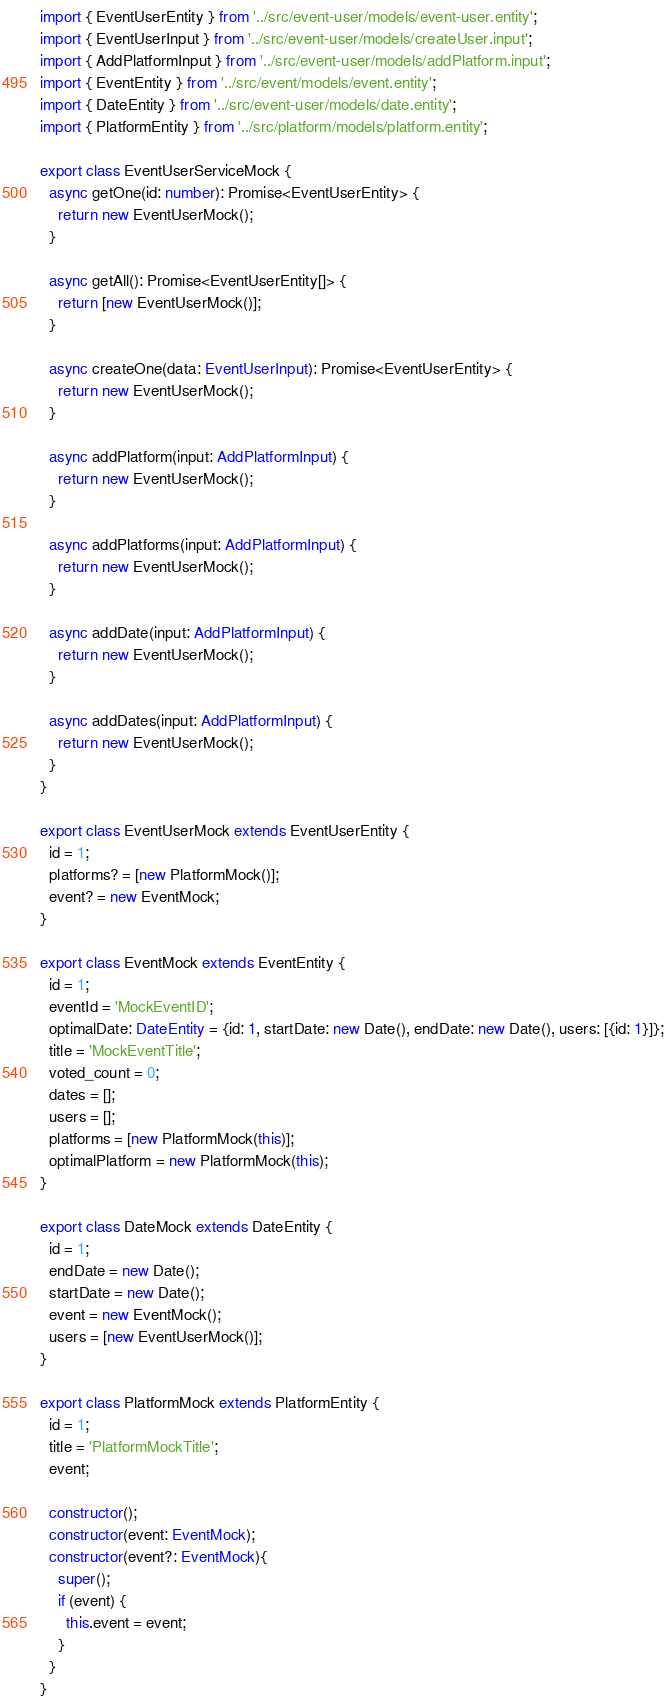<code> <loc_0><loc_0><loc_500><loc_500><_TypeScript_>import { EventUserEntity } from '../src/event-user/models/event-user.entity';
import { EventUserInput } from '../src/event-user/models/createUser.input';
import { AddPlatformInput } from '../src/event-user/models/addPlatform.input';
import { EventEntity } from '../src/event/models/event.entity';
import { DateEntity } from '../src/event-user/models/date.entity';
import { PlatformEntity } from '../src/platform/models/platform.entity';

export class EventUserServiceMock {
  async getOne(id: number): Promise<EventUserEntity> {
    return new EventUserMock();
  }

  async getAll(): Promise<EventUserEntity[]> {
    return [new EventUserMock()];
  }

  async createOne(data: EventUserInput): Promise<EventUserEntity> {
    return new EventUserMock();
  }

  async addPlatform(input: AddPlatformInput) {
    return new EventUserMock();
  }

  async addPlatforms(input: AddPlatformInput) {
    return new EventUserMock();
  }

  async addDate(input: AddPlatformInput) {
    return new EventUserMock();
  }

  async addDates(input: AddPlatformInput) {
    return new EventUserMock();
  }
}

export class EventUserMock extends EventUserEntity {
  id = 1;
  platforms? = [new PlatformMock()];
  event? = new EventMock;
}

export class EventMock extends EventEntity {
  id = 1;
  eventId = 'MockEventID';
  optimalDate: DateEntity = {id: 1, startDate: new Date(), endDate: new Date(), users: [{id: 1}]};
  title = 'MockEventTitle';
  voted_count = 0;
  dates = [];
  users = [];
  platforms = [new PlatformMock(this)];
  optimalPlatform = new PlatformMock(this);
}

export class DateMock extends DateEntity {
  id = 1;
  endDate = new Date();
  startDate = new Date();
  event = new EventMock();
  users = [new EventUserMock()];
}

export class PlatformMock extends PlatformEntity {
  id = 1;
  title = 'PlatformMockTitle';
  event;

  constructor();
  constructor(event: EventMock);
  constructor(event?: EventMock){
    super();
    if (event) {
      this.event = event;
    }
  }
}
</code> 